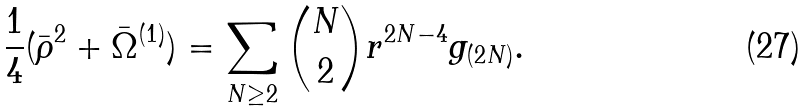Convert formula to latex. <formula><loc_0><loc_0><loc_500><loc_500>\frac { 1 } { 4 } ( \bar { \rho } ^ { 2 } + \bar { \Omega } ^ { ( 1 ) } ) = \sum _ { N \geq 2 } \binom { N } { 2 } r ^ { 2 N - 4 } g _ { ( 2 N ) } .</formula> 